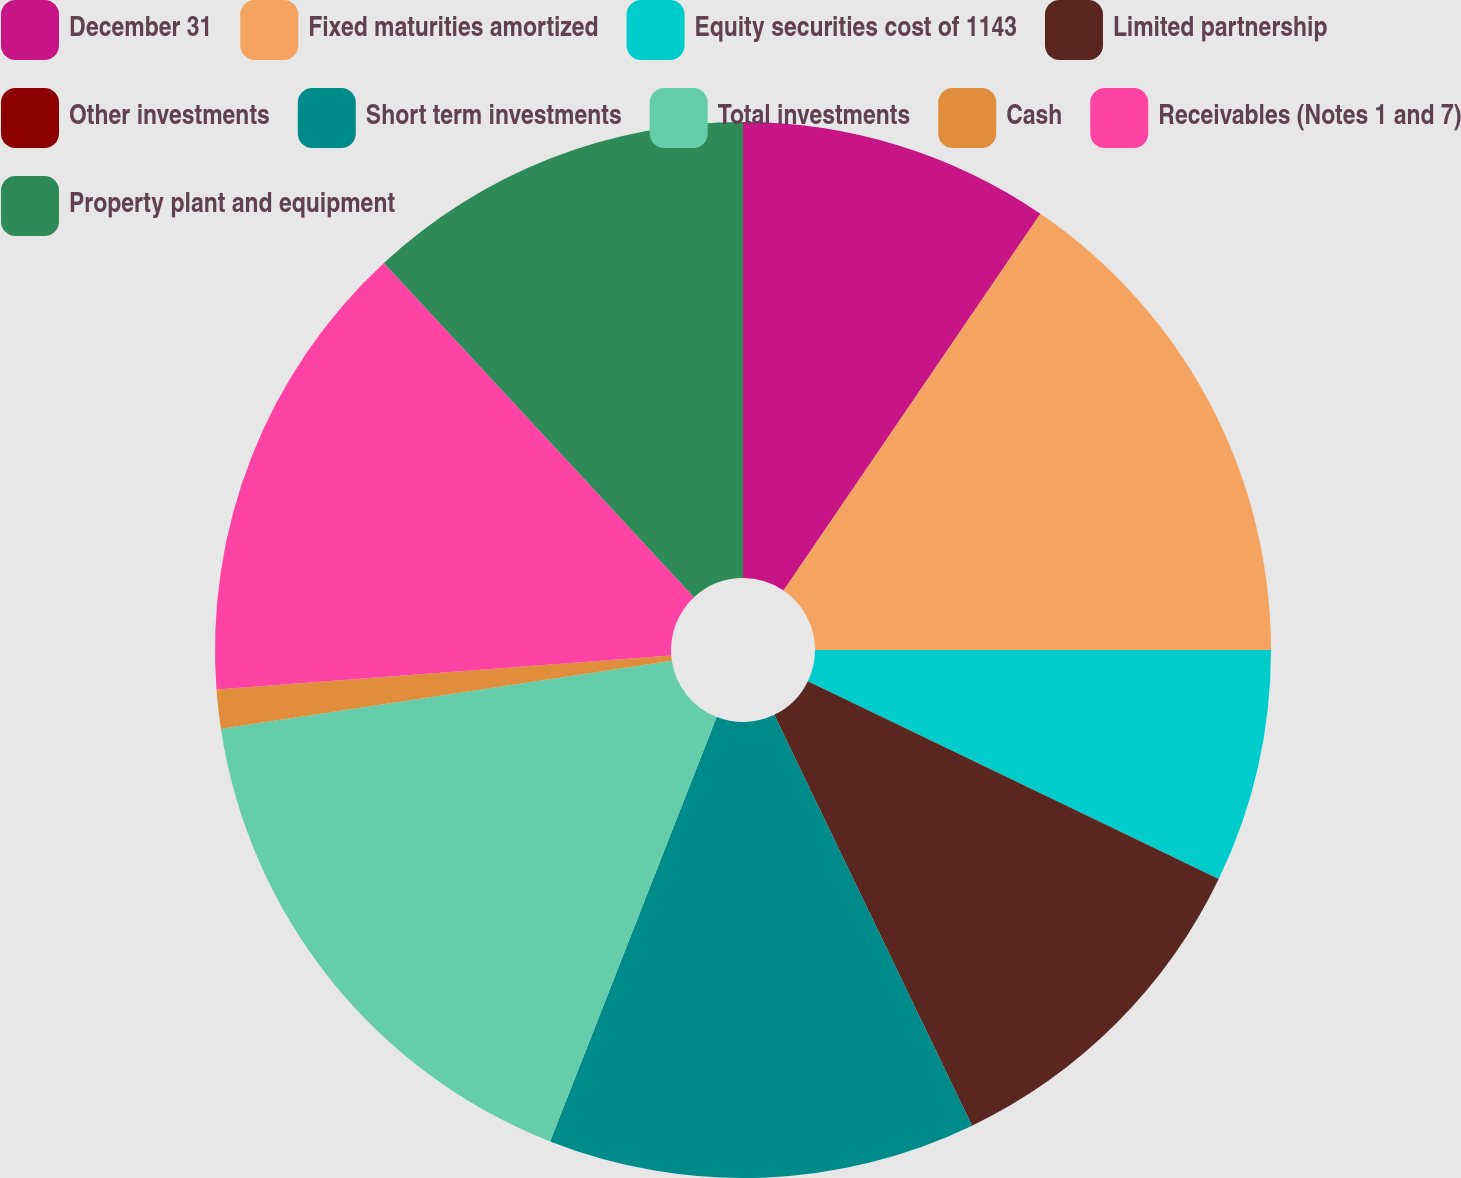<chart> <loc_0><loc_0><loc_500><loc_500><pie_chart><fcel>December 31<fcel>Fixed maturities amortized<fcel>Equity securities cost of 1143<fcel>Limited partnership<fcel>Other investments<fcel>Short term investments<fcel>Total investments<fcel>Cash<fcel>Receivables (Notes 1 and 7)<fcel>Property plant and equipment<nl><fcel>9.52%<fcel>15.47%<fcel>7.14%<fcel>10.71%<fcel>0.0%<fcel>13.09%<fcel>16.66%<fcel>1.19%<fcel>14.28%<fcel>11.9%<nl></chart> 